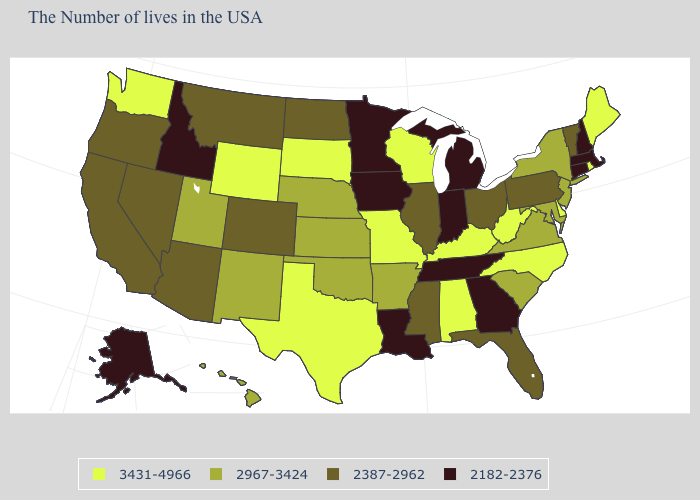What is the value of Vermont?
Keep it brief. 2387-2962. Name the states that have a value in the range 2387-2962?
Keep it brief. Vermont, Pennsylvania, Ohio, Florida, Illinois, Mississippi, North Dakota, Colorado, Montana, Arizona, Nevada, California, Oregon. Is the legend a continuous bar?
Concise answer only. No. Does the first symbol in the legend represent the smallest category?
Keep it brief. No. Name the states that have a value in the range 2182-2376?
Concise answer only. Massachusetts, New Hampshire, Connecticut, Georgia, Michigan, Indiana, Tennessee, Louisiana, Minnesota, Iowa, Idaho, Alaska. What is the value of Louisiana?
Keep it brief. 2182-2376. Is the legend a continuous bar?
Be succinct. No. What is the lowest value in states that border Delaware?
Be succinct. 2387-2962. Does the map have missing data?
Short answer required. No. What is the lowest value in the USA?
Concise answer only. 2182-2376. Among the states that border Vermont , does New York have the lowest value?
Write a very short answer. No. What is the lowest value in the USA?
Keep it brief. 2182-2376. Does the first symbol in the legend represent the smallest category?
Keep it brief. No. Does Mississippi have a higher value than Massachusetts?
Give a very brief answer. Yes. What is the highest value in the USA?
Write a very short answer. 3431-4966. 